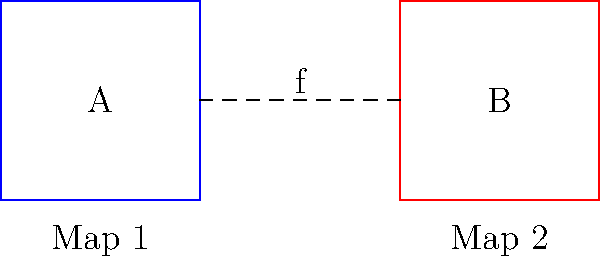Consider two campaign strategy maps A and B, represented by squares, connected by a continuous function f. Are these maps homotopy equivalent? If so, describe a homotopy between them. To determine if the two campaign strategy maps are homotopy equivalent, we need to follow these steps:

1. Understand the concept of homotopy equivalence:
   Two topological spaces are homotopy equivalent if there exists a continuous function between them that can be continuously deformed into the identity map.

2. Analyze the given maps:
   - Both maps A and B are represented by squares, which are topologically equivalent to disks.
   - There exists a continuous function f connecting the two maps.

3. Consider the properties of squares (disks):
   - Squares are contractible spaces, meaning they can be continuously deformed to a point.
   - Any two contractible spaces are homotopy equivalent.

4. Construct a homotopy:
   Let $H : A \times [0,1] \rightarrow B$ be defined as:
   $H(x,t) = (1-t)f(x) + tx_0$
   where $x_0$ is any fixed point in B.

5. Verify the homotopy:
   - At $t=0$, $H(x,0) = f(x)$, which is the original function.
   - At $t=1$, $H(x,1) = x_0$, which maps all points to a single point in B.
   - For $0 < t < 1$, $H$ continuously deforms f to the constant map.

6. Conclude:
   Since we can construct a homotopy between f and a constant map, and both A and B are contractible, the two maps are homotopy equivalent.
Answer: Yes, homotopy equivalent. 